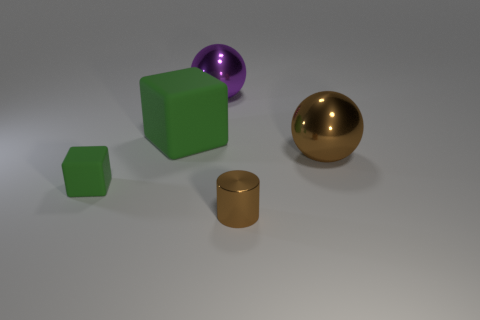Add 3 tiny brown cylinders. How many objects exist? 8 Add 5 green shiny balls. How many green shiny balls exist? 5 Subtract 0 blue cylinders. How many objects are left? 5 Subtract all cylinders. How many objects are left? 4 Subtract all green matte blocks. Subtract all purple metal balls. How many objects are left? 2 Add 3 purple things. How many purple things are left? 4 